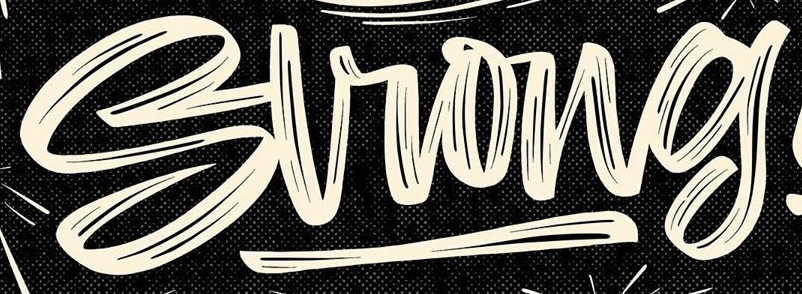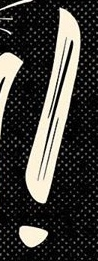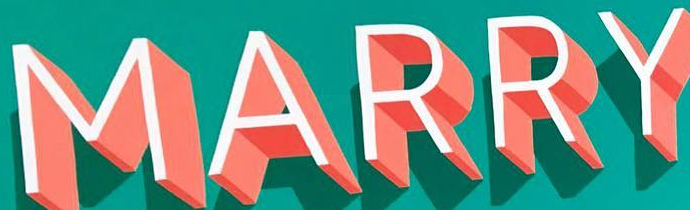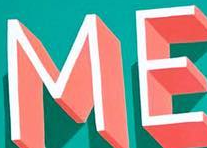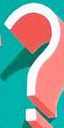Read the text from these images in sequence, separated by a semicolon. Strong; !; MARRY; ME; ? 